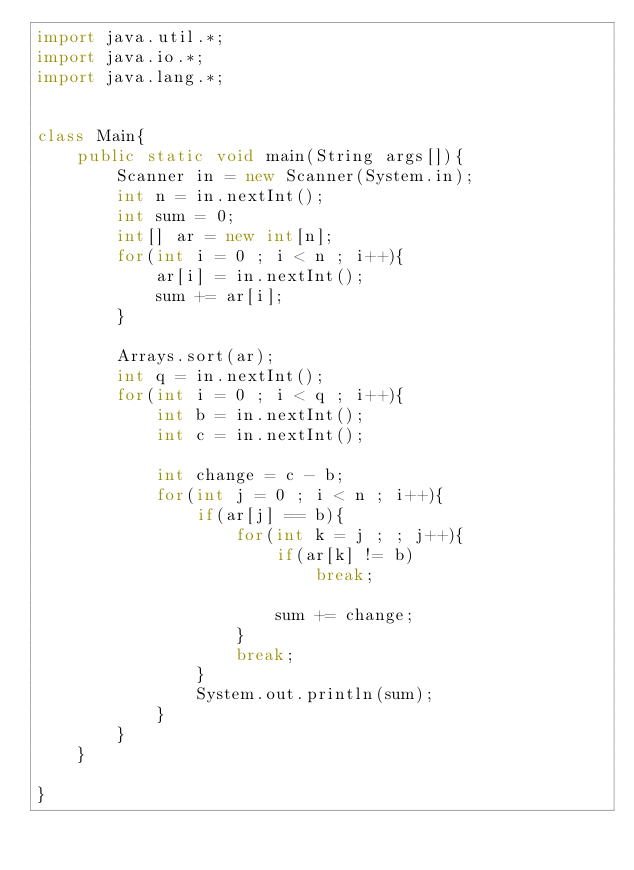<code> <loc_0><loc_0><loc_500><loc_500><_Java_>import java.util.*;
import java.io.*;
import java.lang.*;


class Main{
	public static void main(String args[]){
    	Scanner in = new Scanner(System.in);
      	int n = in.nextInt();
		int sum = 0;
		int[] ar = new int[n];
		for(int i = 0 ; i < n ; i++){
			ar[i] = in.nextInt();
			sum += ar[i];
		}
		
		Arrays.sort(ar);
		int q = in.nextInt();
		for(int i = 0 ; i < q ; i++){
			int b = in.nextInt();
			int c = in.nextInt();

			int change = c - b;
			for(int j = 0 ; i < n ; i++){
				if(ar[j] == b){
					for(int k = j ; ; j++){
						if(ar[k] != b)
							break;

						sum += change;
					}
					break;
				}
				System.out.println(sum);
			}
		}
    }
 
}</code> 